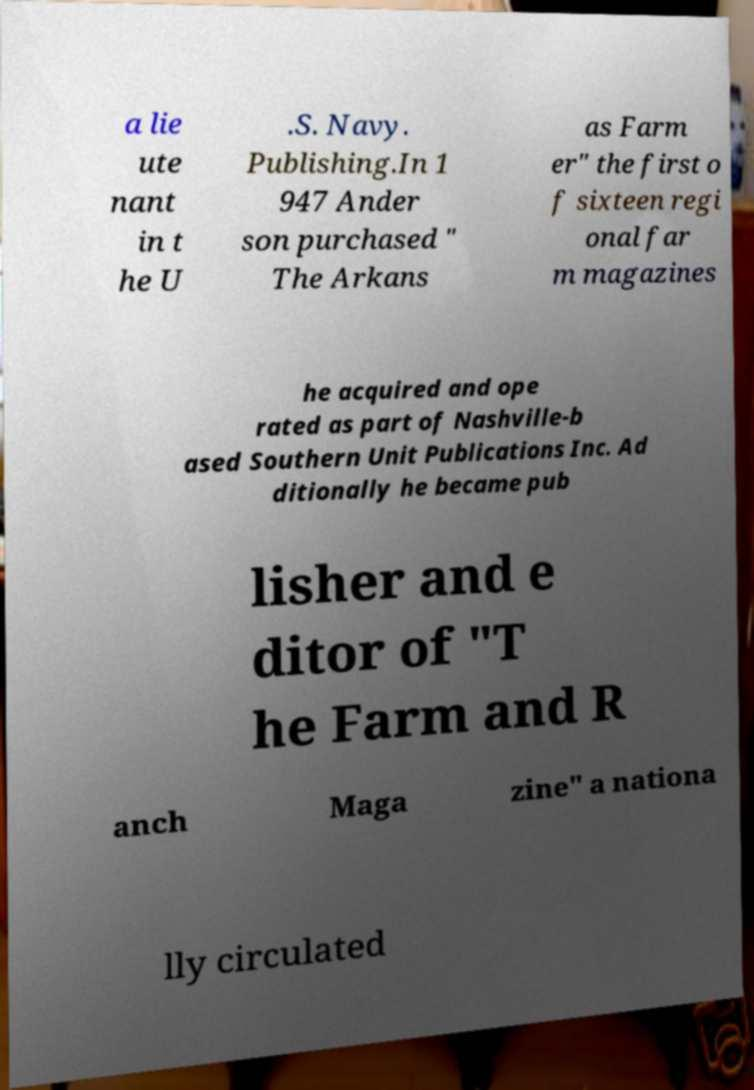There's text embedded in this image that I need extracted. Can you transcribe it verbatim? a lie ute nant in t he U .S. Navy. Publishing.In 1 947 Ander son purchased " The Arkans as Farm er" the first o f sixteen regi onal far m magazines he acquired and ope rated as part of Nashville-b ased Southern Unit Publications Inc. Ad ditionally he became pub lisher and e ditor of "T he Farm and R anch Maga zine" a nationa lly circulated 